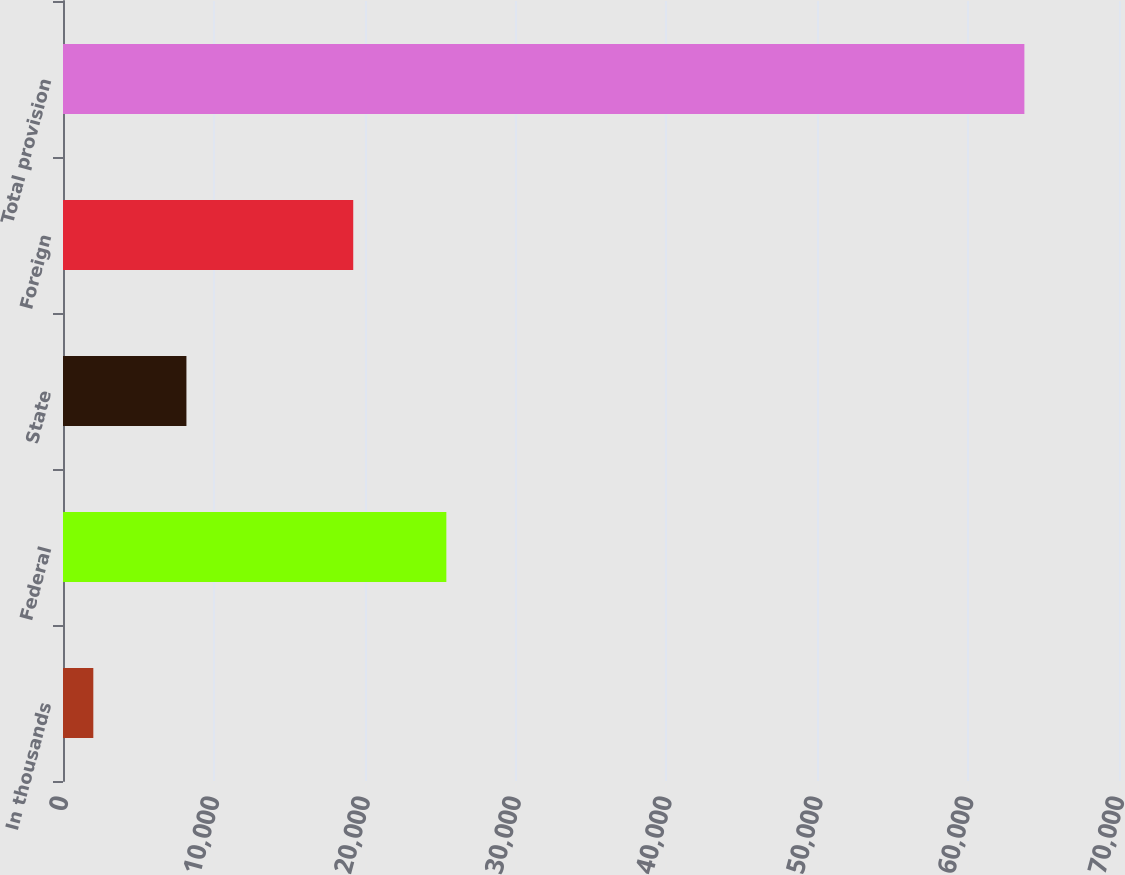Convert chart. <chart><loc_0><loc_0><loc_500><loc_500><bar_chart><fcel>In thousands<fcel>Federal<fcel>State<fcel>Foreign<fcel>Total provision<nl><fcel>2010<fcel>25410.8<fcel>8181.8<fcel>19239<fcel>63728<nl></chart> 